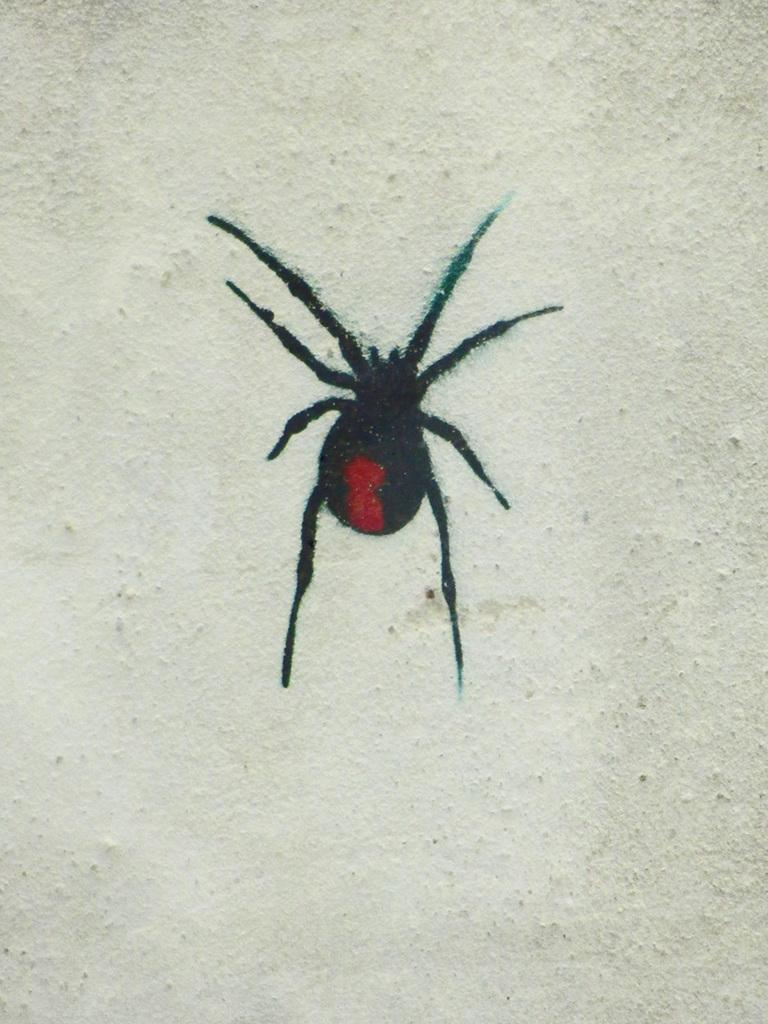What type of creature can be seen in the image? There is an insect in the image. Where is the insect located? The insect is on a white-colored wall. What type of furniture is present in the image? There is no furniture present in the image; it only features an insect on a white-colored wall. What type of meeting is taking place in the image? There is no meeting present in the image; it only features an insect on a white-colored wall. 